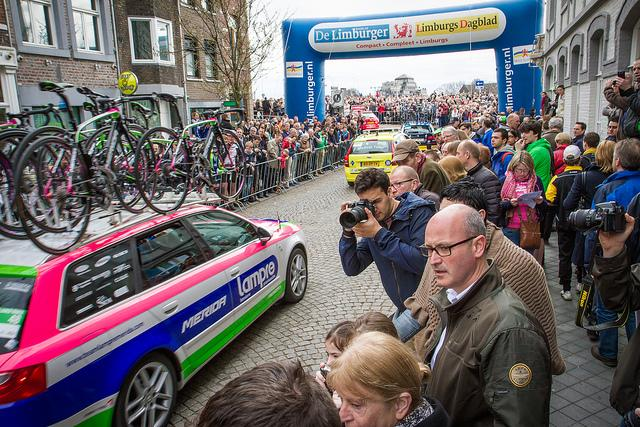What will the man in the blue sweatshirt do next? take photo 